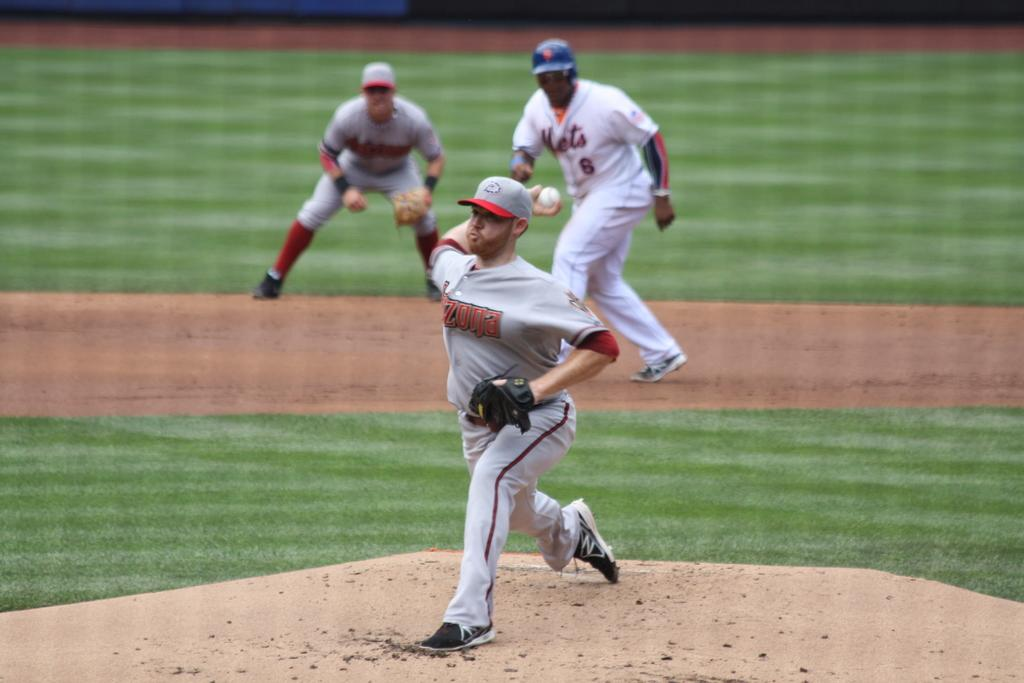<image>
Offer a succinct explanation of the picture presented. A pitcher is pitching a baseball behind player number 6. 